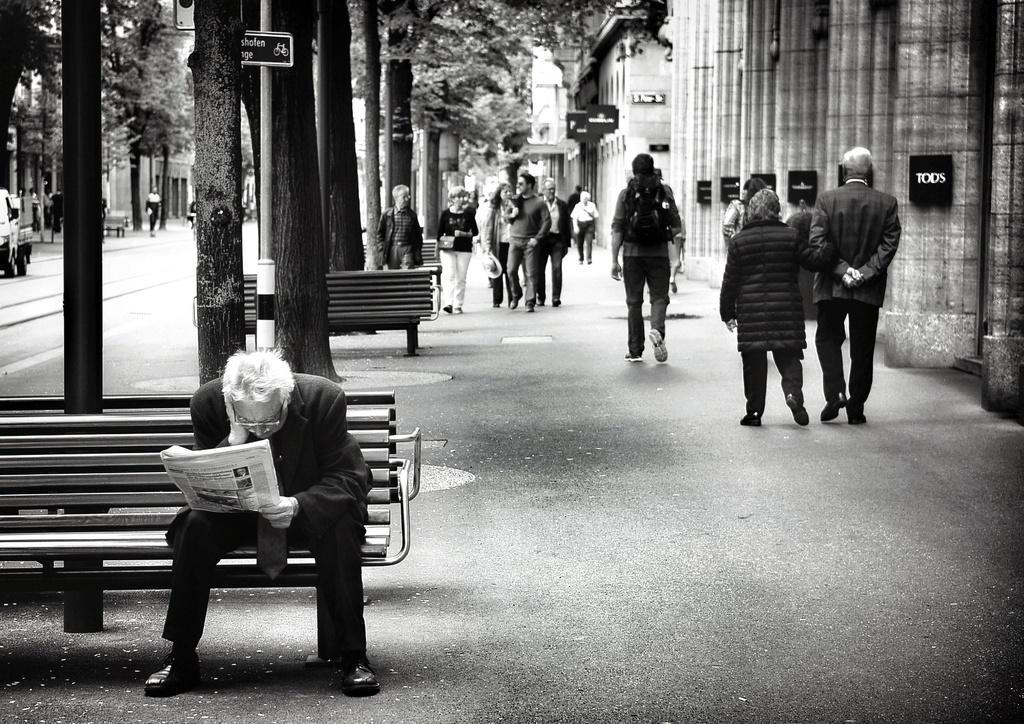Please provide a concise description of this image. In this image, group of people are there. In the middle, a person is sat on the bench, he is reading news paper. And back side, we can see wall, pillars, boards, trees, plants, rods, road. Few are wearing a bags and few are wearing hats , some items. Few are walking on the side platform. 